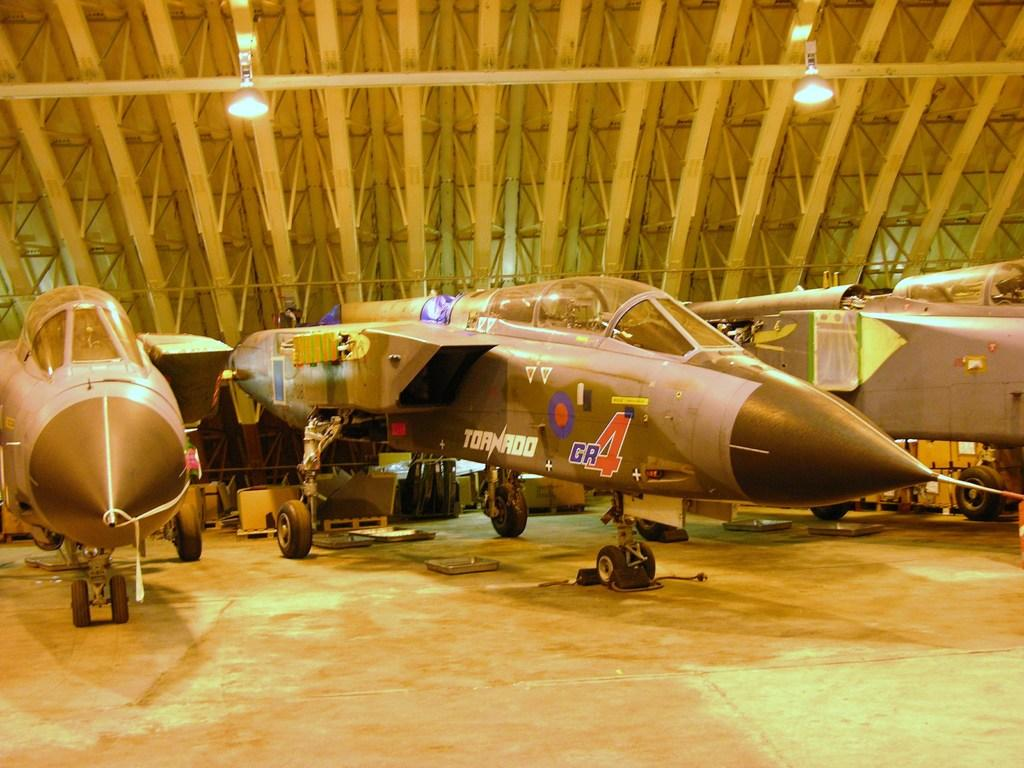<image>
Give a short and clear explanation of the subsequent image. The name of the GR4 jet is Tornado. 